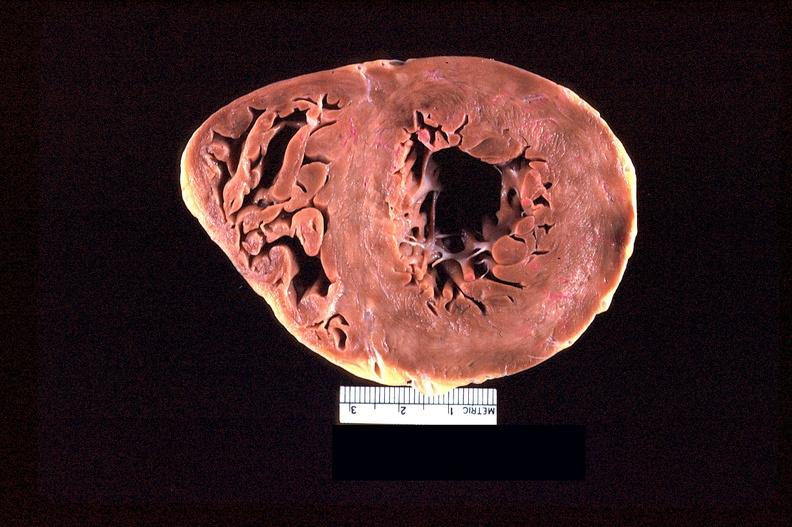does this image show heart slice, acute posterior myocardial infarction in patient with hypertension?
Answer the question using a single word or phrase. Yes 